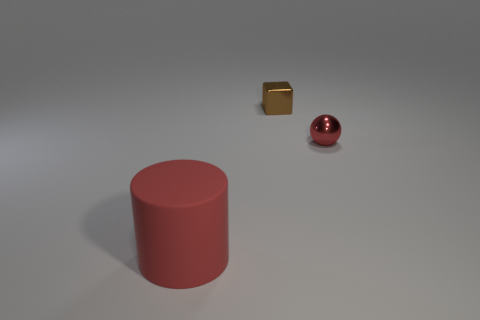What number of cubes are tiny red metallic things or large red things?
Your response must be concise. 0. What number of purple matte cylinders are there?
Keep it short and to the point. 0. There is a large rubber object; is it the same shape as the red object to the right of the rubber thing?
Make the answer very short. No. What size is the red thing that is left of the tiny red metallic object?
Your answer should be very brief. Large. What is the tiny brown thing made of?
Make the answer very short. Metal. Do the small object left of the small red sphere and the red metallic object have the same shape?
Make the answer very short. No. The thing that is the same color as the rubber cylinder is what size?
Offer a terse response. Small. Are there any other metal objects of the same size as the brown object?
Keep it short and to the point. Yes. Are there any cubes that are left of the red object that is to the left of the small object to the right of the brown cube?
Offer a very short reply. No. Do the small sphere and the small metallic thing behind the tiny red object have the same color?
Ensure brevity in your answer.  No. 